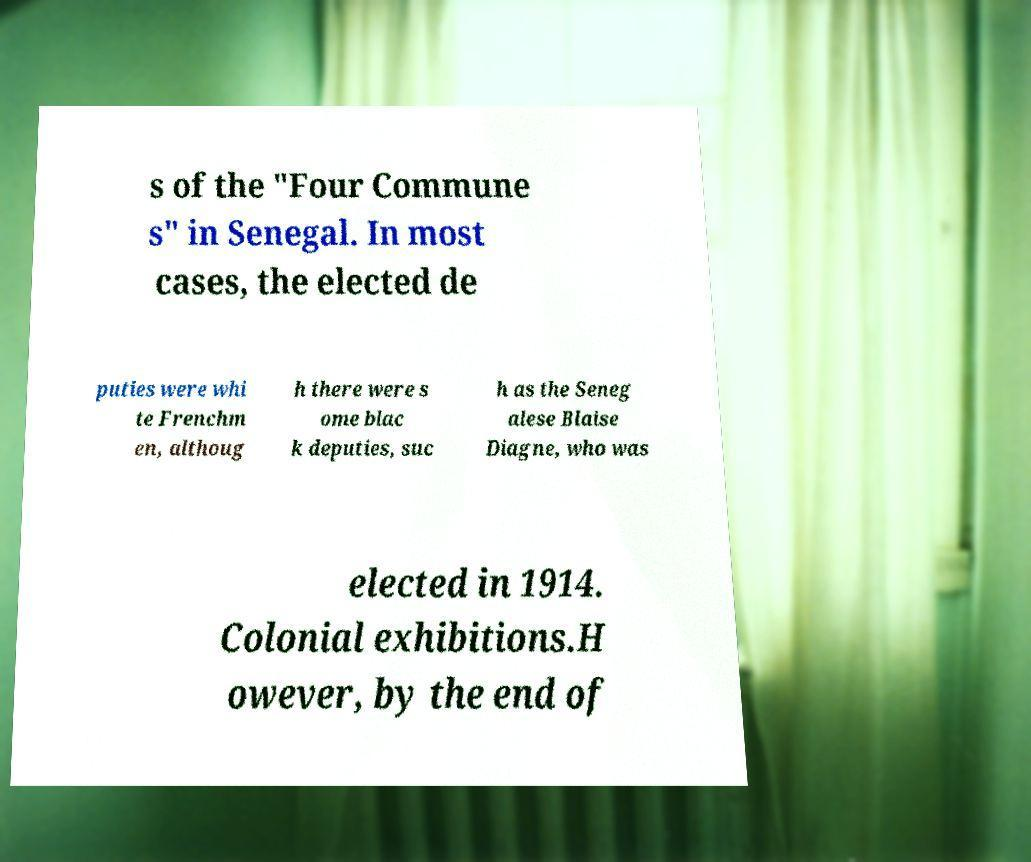Please identify and transcribe the text found in this image. s of the "Four Commune s" in Senegal. In most cases, the elected de puties were whi te Frenchm en, althoug h there were s ome blac k deputies, suc h as the Seneg alese Blaise Diagne, who was elected in 1914. Colonial exhibitions.H owever, by the end of 